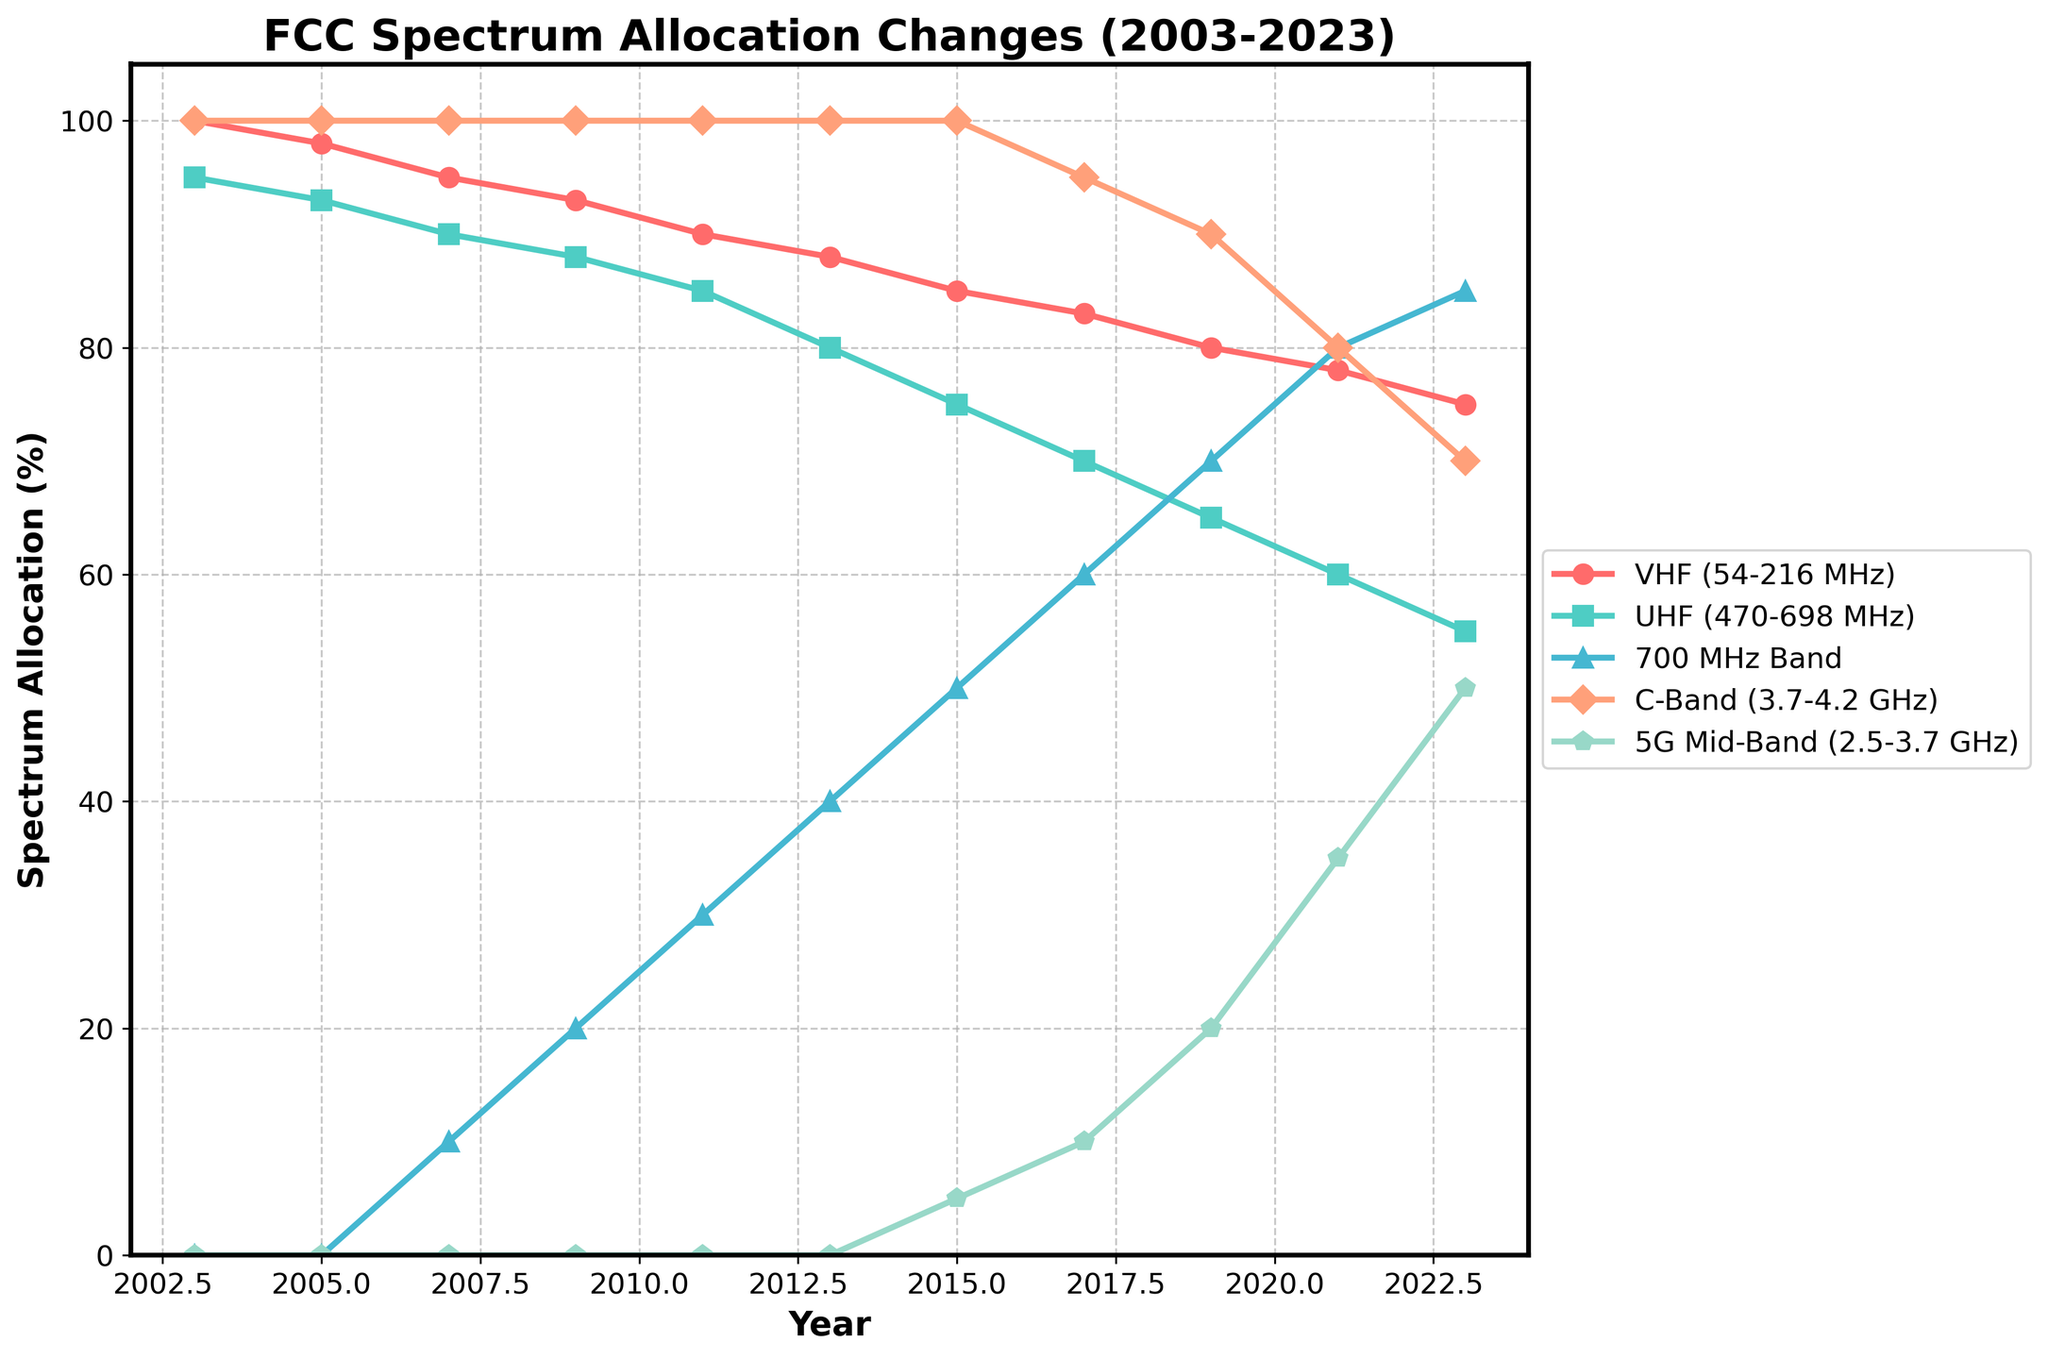Which frequency band experienced the largest initial allocation in 2003? From the figure, the y-axis values represent the percentage allocation for each frequency band in each year. In 2003, the y-axis value for the 'C-Band' (3.7-4.2 GHz) is 100, which is the highest among the frequencies listed for that year.
Answer: C-Band (3.7-4.2 GHz) From 2003 to 2023, which frequency band shows the most significant increase in allocation percentage? We need to compare the allocation percentages in 2003 and 2023 for each band. The '5G Mid-Band' (2.5-3.7 GHz) shows an increase from 0% to 50%, which is the highest increase among all the bands.
Answer: 5G Mid-Band (2.5-3.7 GHz) In which year did the 700 MHz Band reach a 50% allocation? By analyzing the 700 MHz Band's plot line, it reaches the 50% allocation mark in 2015.
Answer: 2015 Which frequency bands had their allocation decreased between 2019 and 2023? By examining the downward trends between 2019 and 2023, the 'VHF' (54-216 MHz), 'UHF' (470-698 MHz), and 'C-Band' (3.7-4.2 GHz) bands all show a decrease.
Answer: VHF, UHF, C-Band What is the combined allocation percentage of VHF and UHF in 2021? Add the values from the VHF and UHF bands in 2021. VHF (78%) + UHF (60%) = 138%.
Answer: 138% Which frequency band had the lowest allocation in 2007? From the figure, the y-axis value for the '5G Mid-Band' (2.5-3.7 GHz) is 0%, lower than the others in 2007.
Answer: 5G Mid-Band (2.5-3.7 GHz) Between 2009 and 2013, which frequency band had the most consistent allocation percentage? The 'C-Band' (3.7-4.2 GHz) remains at 100% during this period, indicating the most consistency.
Answer: C-Band (3.7-4.2 GHz) By how much did the 5G Mid-Band increase from 2015 to 2023? The percentage allocation of the 5G Mid-Band in 2015 was 5%, and in 2023 it was 50%. The increase is 50% - 5% = 45%.
Answer: 45% Which frequency band showed a steady decline over the 20-year period? The 'UHF' (470-698 MHz) consistently declined from 95% in 2003 to 55% in 2023.
Answer: UHF (470-698 MHz) In 2019, which frequency band had a higher allocation, the 700 MHz Band or the 5G Mid-Band? Comparing the allocation values in 2019, the 700 MHz Band is at 70%, while the 5G Mid-Band is at 20%. Thus, the 700 MHz Band had a higher allocation.
Answer: 700 MHz Band 